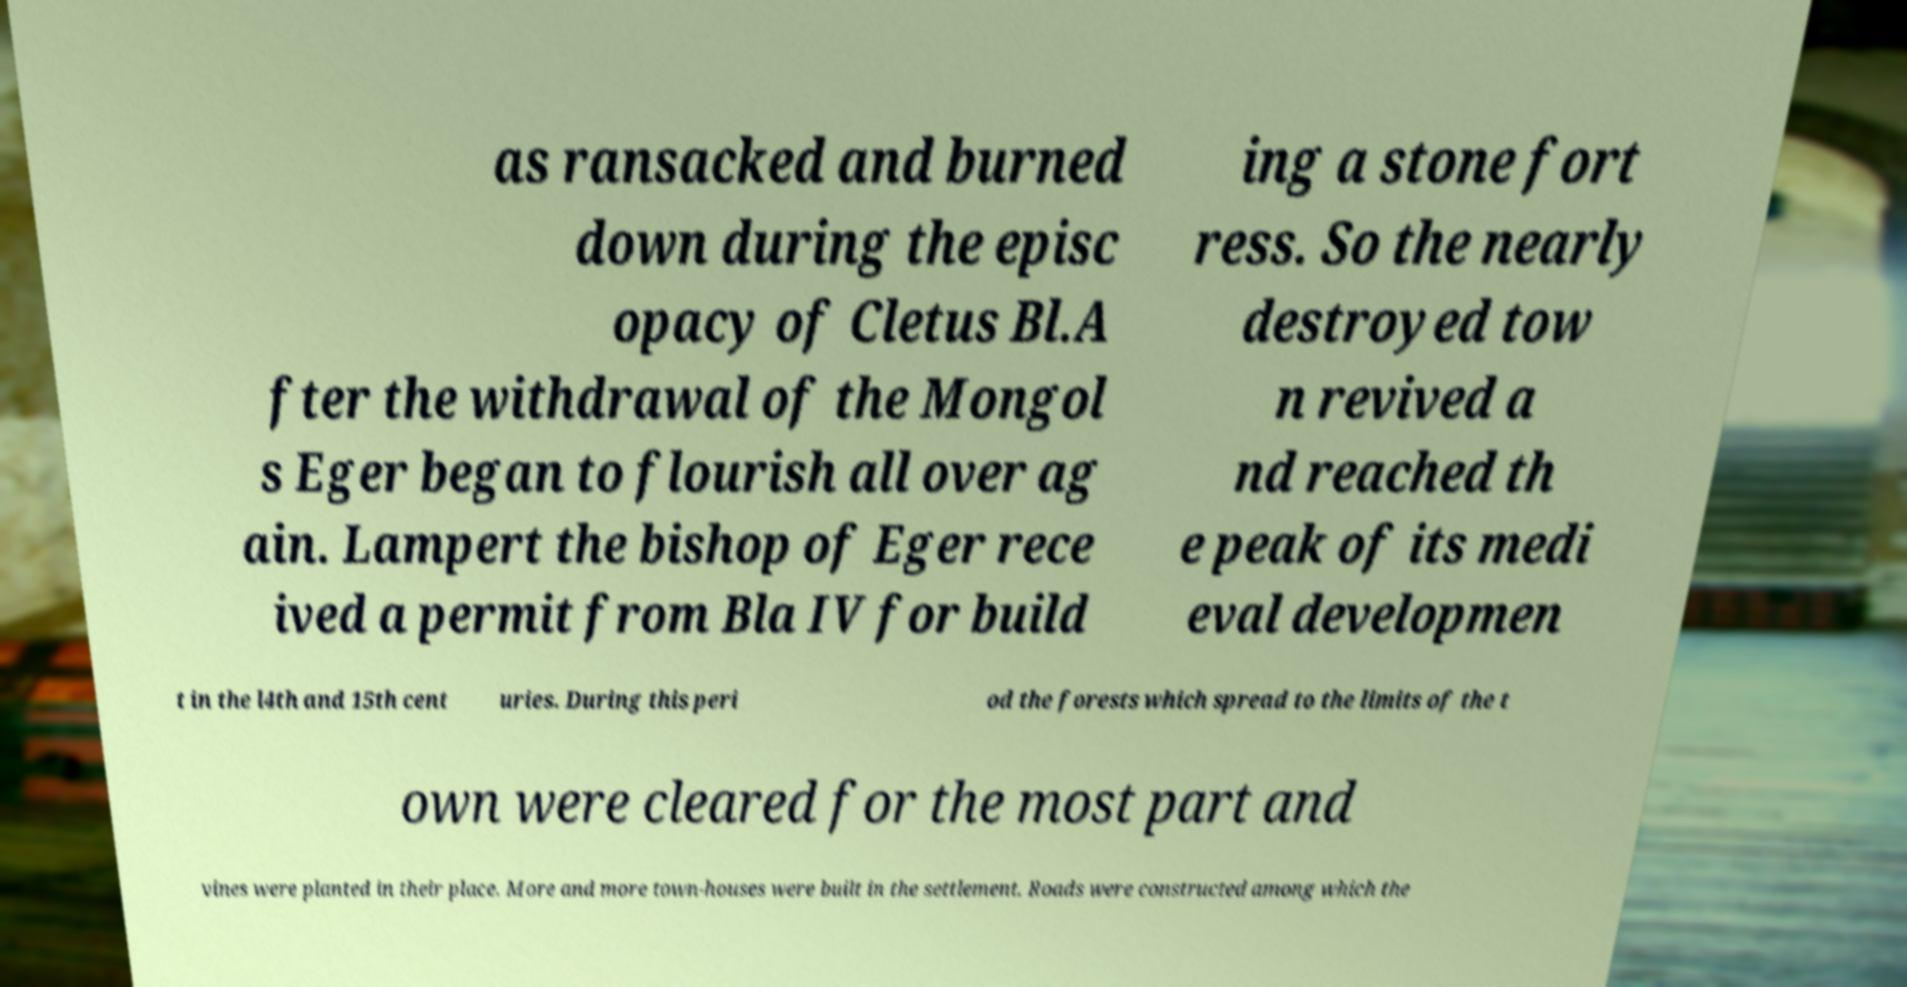Please identify and transcribe the text found in this image. as ransacked and burned down during the episc opacy of Cletus Bl.A fter the withdrawal of the Mongol s Eger began to flourish all over ag ain. Lampert the bishop of Eger rece ived a permit from Bla IV for build ing a stone fort ress. So the nearly destroyed tow n revived a nd reached th e peak of its medi eval developmen t in the l4th and 15th cent uries. During this peri od the forests which spread to the limits of the t own were cleared for the most part and vines were planted in their place. More and more town-houses were built in the settlement. Roads were constructed among which the 